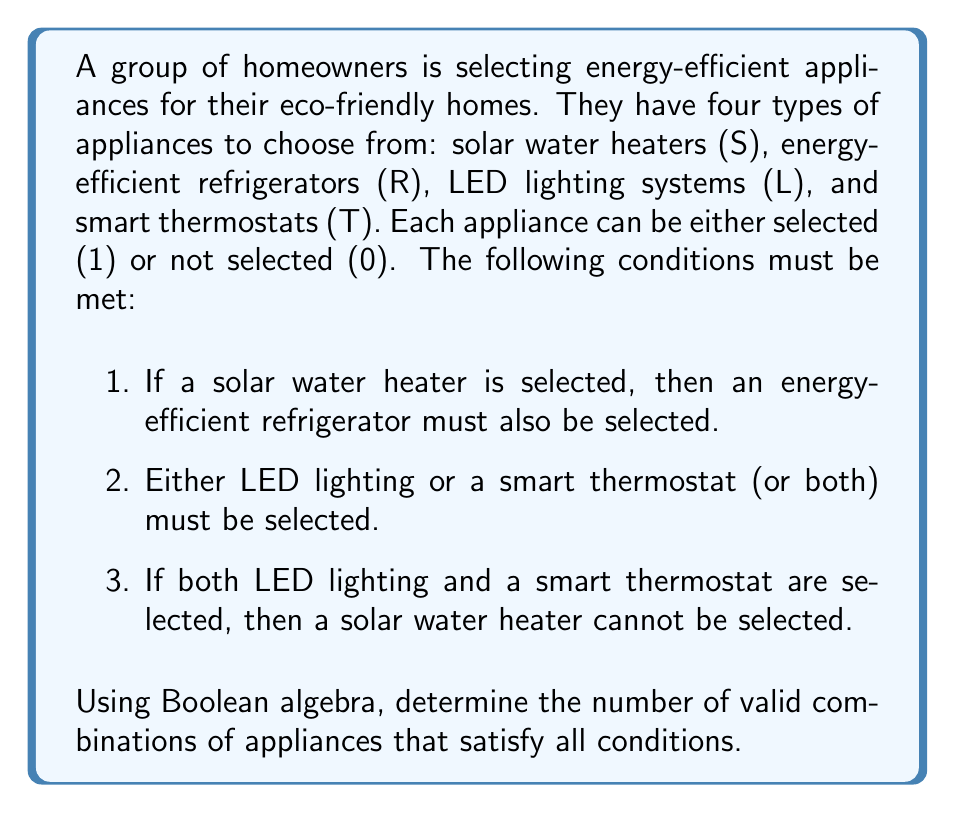Solve this math problem. Let's approach this step-by-step using Boolean algebra:

1) First, let's express the conditions using Boolean expressions:
   a) $S \Rightarrow R$ (If S, then R)
   b) $L \lor T$ (L or T or both)
   c) $(L \land T) \Rightarrow \neg S$ (If L and T, then not S)

2) We can simplify condition (a) as: $\neg S \lor R$

3) The overall Boolean expression for valid combinations is:
   $F = (\neg S \lor R) \land (L \lor T) \land (\neg(L \land T) \lor \neg S)$

4) Expanding this expression:
   $F = (\neg S \lor R) \land (L \lor T) \land (\neg L \lor \neg T \lor \neg S)$

5) To count the valid combinations, we need to evaluate this expression for all possible input combinations. There are $2^4 = 16$ possible combinations for S, R, L, and T.

6) Let's create a truth table:

   $$ \begin{array}{|c|c|c|c|c|c|c|c|}
   \hline
   S & R & L & T & \neg S \lor R & L \lor T & \neg L \lor \neg T \lor \neg S & F \\
   \hline
   0 & 0 & 0 & 0 & 1 & 0 & 1 & 0 \\
   0 & 0 & 0 & 1 & 1 & 1 & 1 & 1 \\
   0 & 0 & 1 & 0 & 1 & 1 & 1 & 1 \\
   0 & 0 & 1 & 1 & 1 & 1 & 1 & 1 \\
   0 & 1 & 0 & 0 & 1 & 0 & 1 & 0 \\
   0 & 1 & 0 & 1 & 1 & 1 & 1 & 1 \\
   0 & 1 & 1 & 0 & 1 & 1 & 1 & 1 \\
   0 & 1 & 1 & 1 & 1 & 1 & 1 & 1 \\
   1 & 0 & 0 & 0 & 0 & 0 & 1 & 0 \\
   1 & 0 & 0 & 1 & 0 & 1 & 1 & 0 \\
   1 & 0 & 1 & 0 & 0 & 1 & 1 & 0 \\
   1 & 0 & 1 & 1 & 0 & 1 & 0 & 0 \\
   1 & 1 & 0 & 0 & 1 & 0 & 1 & 0 \\
   1 & 1 & 0 & 1 & 1 & 1 & 1 & 1 \\
   1 & 1 & 1 & 0 & 1 & 1 & 1 & 1 \\
   1 & 1 & 1 & 1 & 1 & 1 & 0 & 0 \\
   \hline
   \end{array} $$

7) Counting the number of 1's in the F column gives us the number of valid combinations.
Answer: 8 